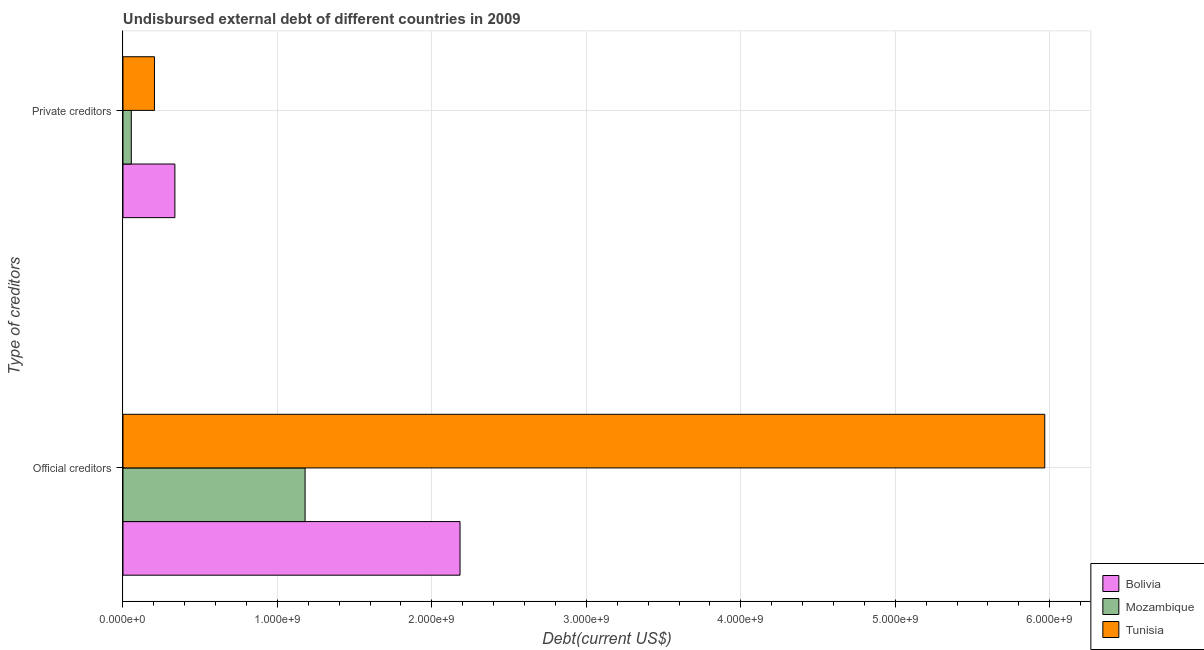How many different coloured bars are there?
Offer a terse response. 3. How many groups of bars are there?
Your answer should be very brief. 2. What is the label of the 2nd group of bars from the top?
Offer a terse response. Official creditors. What is the undisbursed external debt of official creditors in Tunisia?
Provide a succinct answer. 5.97e+09. Across all countries, what is the maximum undisbursed external debt of official creditors?
Give a very brief answer. 5.97e+09. Across all countries, what is the minimum undisbursed external debt of official creditors?
Keep it short and to the point. 1.18e+09. In which country was the undisbursed external debt of official creditors maximum?
Your answer should be compact. Tunisia. In which country was the undisbursed external debt of private creditors minimum?
Your response must be concise. Mozambique. What is the total undisbursed external debt of private creditors in the graph?
Provide a succinct answer. 5.94e+08. What is the difference between the undisbursed external debt of official creditors in Mozambique and that in Bolivia?
Offer a very short reply. -1.00e+09. What is the difference between the undisbursed external debt of private creditors in Mozambique and the undisbursed external debt of official creditors in Tunisia?
Keep it short and to the point. -5.91e+09. What is the average undisbursed external debt of official creditors per country?
Give a very brief answer. 3.11e+09. What is the difference between the undisbursed external debt of private creditors and undisbursed external debt of official creditors in Bolivia?
Your answer should be very brief. -1.85e+09. What is the ratio of the undisbursed external debt of official creditors in Bolivia to that in Tunisia?
Offer a very short reply. 0.37. What does the 2nd bar from the top in Private creditors represents?
Keep it short and to the point. Mozambique. What does the 2nd bar from the bottom in Official creditors represents?
Your answer should be very brief. Mozambique. Are all the bars in the graph horizontal?
Your response must be concise. Yes. How many countries are there in the graph?
Provide a short and direct response. 3. Are the values on the major ticks of X-axis written in scientific E-notation?
Keep it short and to the point. Yes. Does the graph contain grids?
Make the answer very short. Yes. Where does the legend appear in the graph?
Make the answer very short. Bottom right. What is the title of the graph?
Keep it short and to the point. Undisbursed external debt of different countries in 2009. What is the label or title of the X-axis?
Make the answer very short. Debt(current US$). What is the label or title of the Y-axis?
Give a very brief answer. Type of creditors. What is the Debt(current US$) of Bolivia in Official creditors?
Provide a short and direct response. 2.18e+09. What is the Debt(current US$) in Mozambique in Official creditors?
Provide a succinct answer. 1.18e+09. What is the Debt(current US$) in Tunisia in Official creditors?
Offer a terse response. 5.97e+09. What is the Debt(current US$) of Bolivia in Private creditors?
Make the answer very short. 3.36e+08. What is the Debt(current US$) in Mozambique in Private creditors?
Offer a terse response. 5.40e+07. What is the Debt(current US$) of Tunisia in Private creditors?
Provide a short and direct response. 2.04e+08. Across all Type of creditors, what is the maximum Debt(current US$) in Bolivia?
Offer a terse response. 2.18e+09. Across all Type of creditors, what is the maximum Debt(current US$) in Mozambique?
Your answer should be compact. 1.18e+09. Across all Type of creditors, what is the maximum Debt(current US$) of Tunisia?
Provide a short and direct response. 5.97e+09. Across all Type of creditors, what is the minimum Debt(current US$) of Bolivia?
Ensure brevity in your answer.  3.36e+08. Across all Type of creditors, what is the minimum Debt(current US$) of Mozambique?
Give a very brief answer. 5.40e+07. Across all Type of creditors, what is the minimum Debt(current US$) in Tunisia?
Keep it short and to the point. 2.04e+08. What is the total Debt(current US$) of Bolivia in the graph?
Your answer should be compact. 2.52e+09. What is the total Debt(current US$) in Mozambique in the graph?
Offer a terse response. 1.23e+09. What is the total Debt(current US$) of Tunisia in the graph?
Ensure brevity in your answer.  6.17e+09. What is the difference between the Debt(current US$) in Bolivia in Official creditors and that in Private creditors?
Make the answer very short. 1.85e+09. What is the difference between the Debt(current US$) of Mozambique in Official creditors and that in Private creditors?
Provide a short and direct response. 1.13e+09. What is the difference between the Debt(current US$) of Tunisia in Official creditors and that in Private creditors?
Your answer should be compact. 5.76e+09. What is the difference between the Debt(current US$) of Bolivia in Official creditors and the Debt(current US$) of Mozambique in Private creditors?
Your response must be concise. 2.13e+09. What is the difference between the Debt(current US$) of Bolivia in Official creditors and the Debt(current US$) of Tunisia in Private creditors?
Give a very brief answer. 1.98e+09. What is the difference between the Debt(current US$) of Mozambique in Official creditors and the Debt(current US$) of Tunisia in Private creditors?
Provide a short and direct response. 9.75e+08. What is the average Debt(current US$) in Bolivia per Type of creditors?
Your answer should be very brief. 1.26e+09. What is the average Debt(current US$) in Mozambique per Type of creditors?
Keep it short and to the point. 6.17e+08. What is the average Debt(current US$) of Tunisia per Type of creditors?
Ensure brevity in your answer.  3.09e+09. What is the difference between the Debt(current US$) in Bolivia and Debt(current US$) in Mozambique in Official creditors?
Your response must be concise. 1.00e+09. What is the difference between the Debt(current US$) of Bolivia and Debt(current US$) of Tunisia in Official creditors?
Provide a short and direct response. -3.79e+09. What is the difference between the Debt(current US$) of Mozambique and Debt(current US$) of Tunisia in Official creditors?
Give a very brief answer. -4.79e+09. What is the difference between the Debt(current US$) of Bolivia and Debt(current US$) of Mozambique in Private creditors?
Offer a terse response. 2.82e+08. What is the difference between the Debt(current US$) in Bolivia and Debt(current US$) in Tunisia in Private creditors?
Make the answer very short. 1.32e+08. What is the difference between the Debt(current US$) in Mozambique and Debt(current US$) in Tunisia in Private creditors?
Your response must be concise. -1.50e+08. What is the ratio of the Debt(current US$) in Bolivia in Official creditors to that in Private creditors?
Your answer should be compact. 6.49. What is the ratio of the Debt(current US$) in Mozambique in Official creditors to that in Private creditors?
Your answer should be compact. 21.85. What is the ratio of the Debt(current US$) in Tunisia in Official creditors to that in Private creditors?
Offer a terse response. 29.28. What is the difference between the highest and the second highest Debt(current US$) in Bolivia?
Provide a succinct answer. 1.85e+09. What is the difference between the highest and the second highest Debt(current US$) in Mozambique?
Your response must be concise. 1.13e+09. What is the difference between the highest and the second highest Debt(current US$) in Tunisia?
Keep it short and to the point. 5.76e+09. What is the difference between the highest and the lowest Debt(current US$) of Bolivia?
Provide a succinct answer. 1.85e+09. What is the difference between the highest and the lowest Debt(current US$) of Mozambique?
Offer a terse response. 1.13e+09. What is the difference between the highest and the lowest Debt(current US$) in Tunisia?
Give a very brief answer. 5.76e+09. 